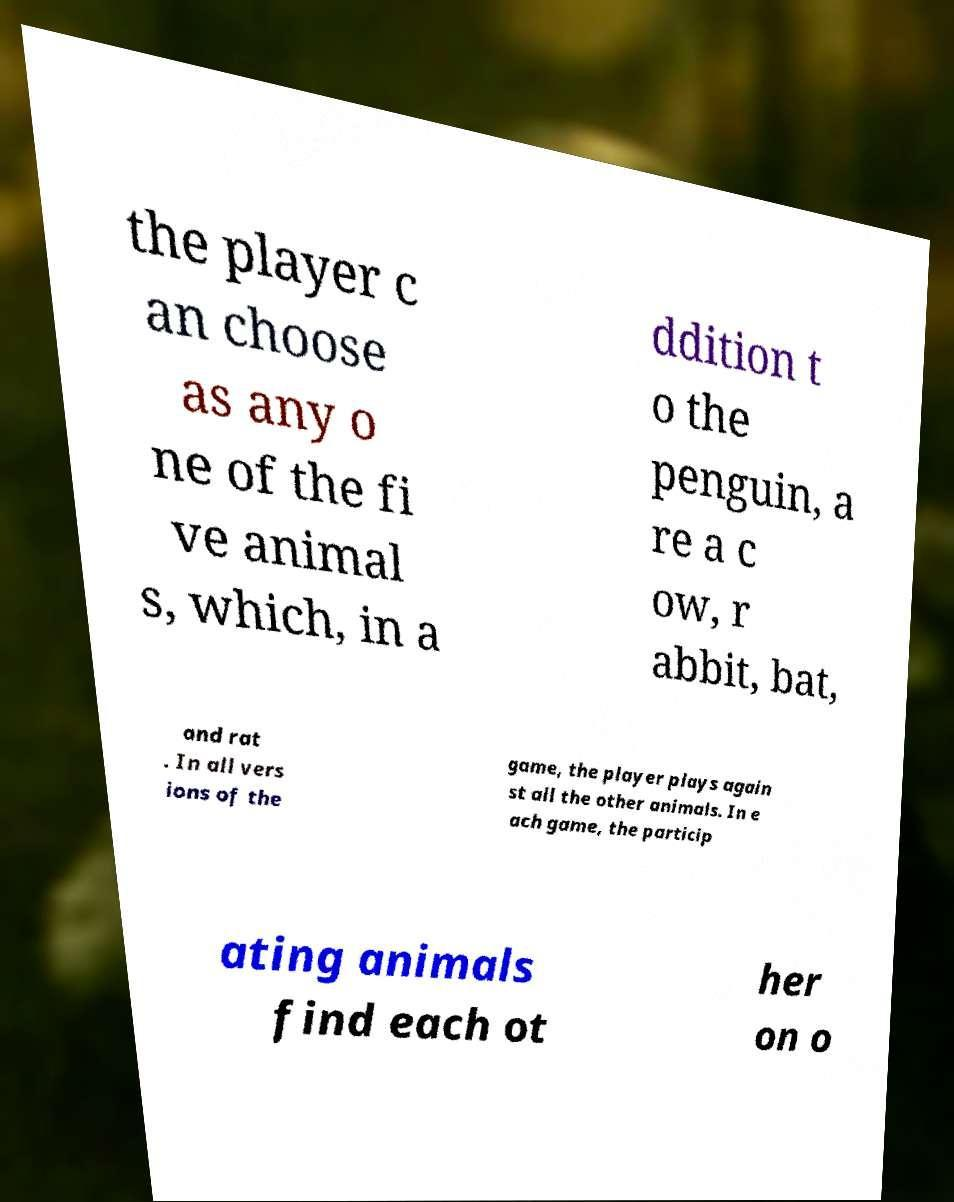Can you accurately transcribe the text from the provided image for me? the player c an choose as any o ne of the fi ve animal s, which, in a ddition t o the penguin, a re a c ow, r abbit, bat, and rat . In all vers ions of the game, the player plays again st all the other animals. In e ach game, the particip ating animals find each ot her on o 